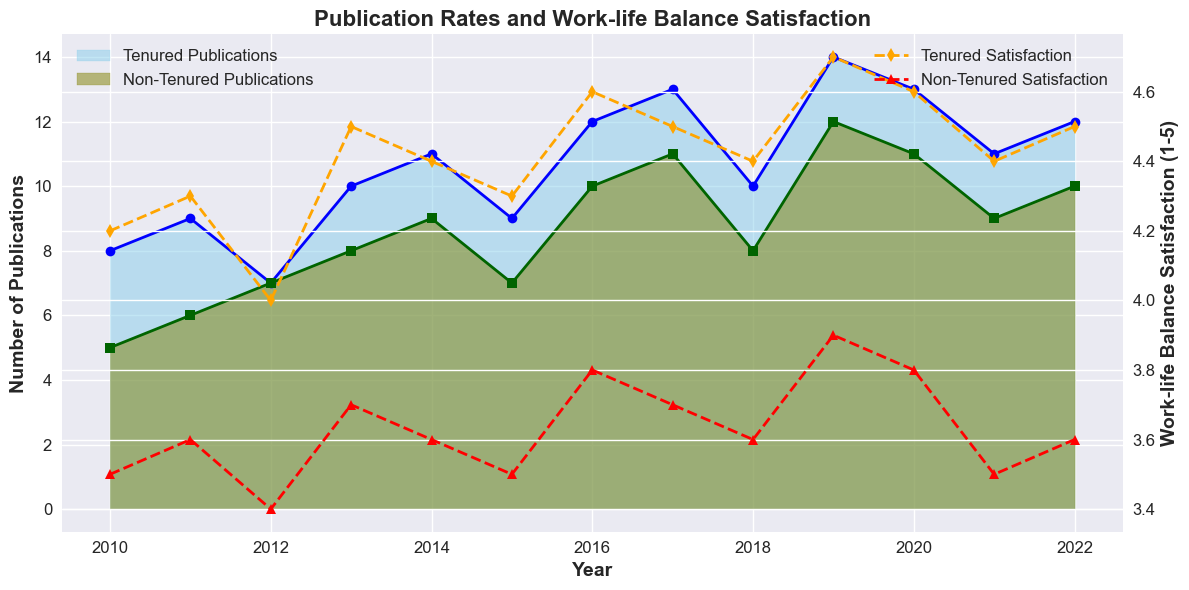What trends can be observed in publication rates for tenured professors from 2010 to 2022? The tenured publication rates show an overall increasing trend with some fluctuations. Notable increases occur around 2013, 2014, and 2019 with slight decreases or plateauing in years like 2012 and between 2020 to 2021.
Answer: Increasing trend with fluctuations What are the differences in work-life balance satisfaction scores between tenured and non-tenured professors in 2013? In 2013, tenured professors had a work-life balance satisfaction score of 4.5, while non-tenured professors had a score of 3.7. The difference is calculated as 4.5 - 3.7.
Answer: 0.8 In which year did non-tenured professors have their highest publication rate, and what was the rate? The highest publication rate for non-tenured professors occurred in 2019, with a rate of 12 publications. This can be observed by examining the peak in the olive-colored area on the chart.
Answer: 2019 and 12 publications How did the work-life balance satisfaction of tenured professors change from 2010 to 2022? The work-life balance satisfaction of tenured professors was generally high, starting at 4.2 in 2010, reaching a peak around 2019 at 4.7, and ending at 4.5 in 2022. There are minor fluctuations, but the overall trend remains relatively stable and positive.
Answer: Generally stable with minor fluctuations, ending at 4.5 Compare the publication rates of tenured and non-tenured professors in 2015. Which group had a higher rate, and by how much? In 2015, tenured professors had 9 publications, while non-tenured professors had 7. The difference in their publication rates is 9 - 7.
Answer: Tenured professors by 2 What is the average work-life balance satisfaction for non-tenured professors across the entire period? The average work-life balance satisfaction for non-tenured professors can be calculated by summing their scores and dividing by the total number of years. The total satisfaction scores sum to 47.6 over 13 years, so the average is 47.6 / 13.
Answer: 3.66 Which year shows the closest publication rates between tenured and non-tenured professors? In 2012, both tenured and non-tenured professors had the same publication rate of 7. By observing the overlap or closest points of the sky-blue and olive areas, this year stands out.
Answer: 2012 Identify the color used to represent the work-life balance satisfaction of non-tenured professors. The work-life balance satisfaction for non-tenured professors is represented by a red dashed line with triangle markers.
Answer: Red 